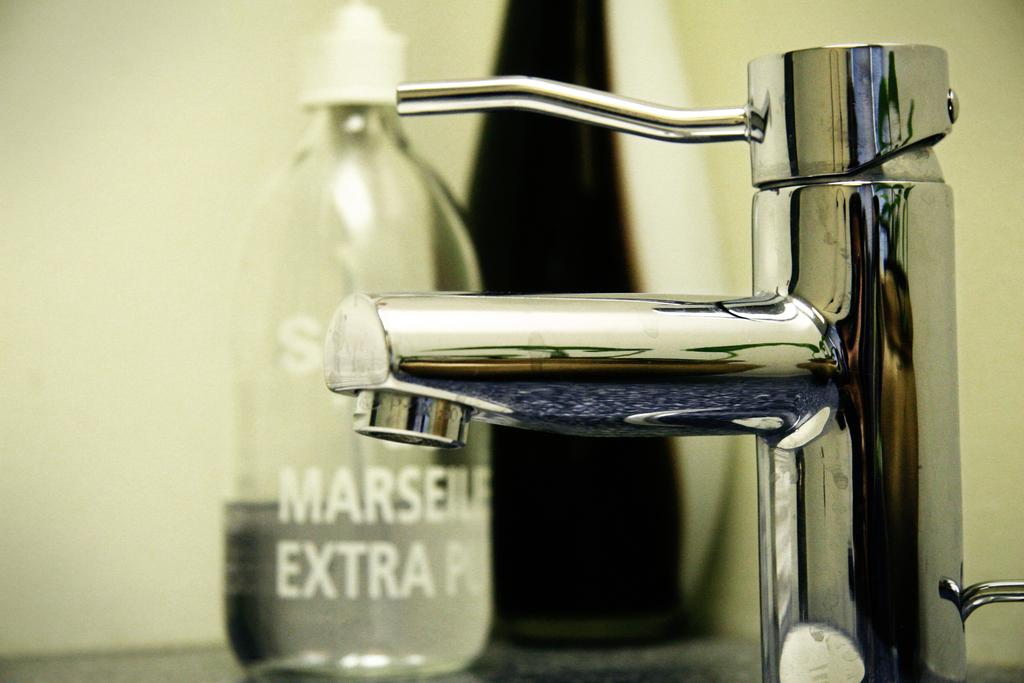<image>
Describe the image concisely. A bottle of soap with the word EXTRA sits behind a sink faucet. 